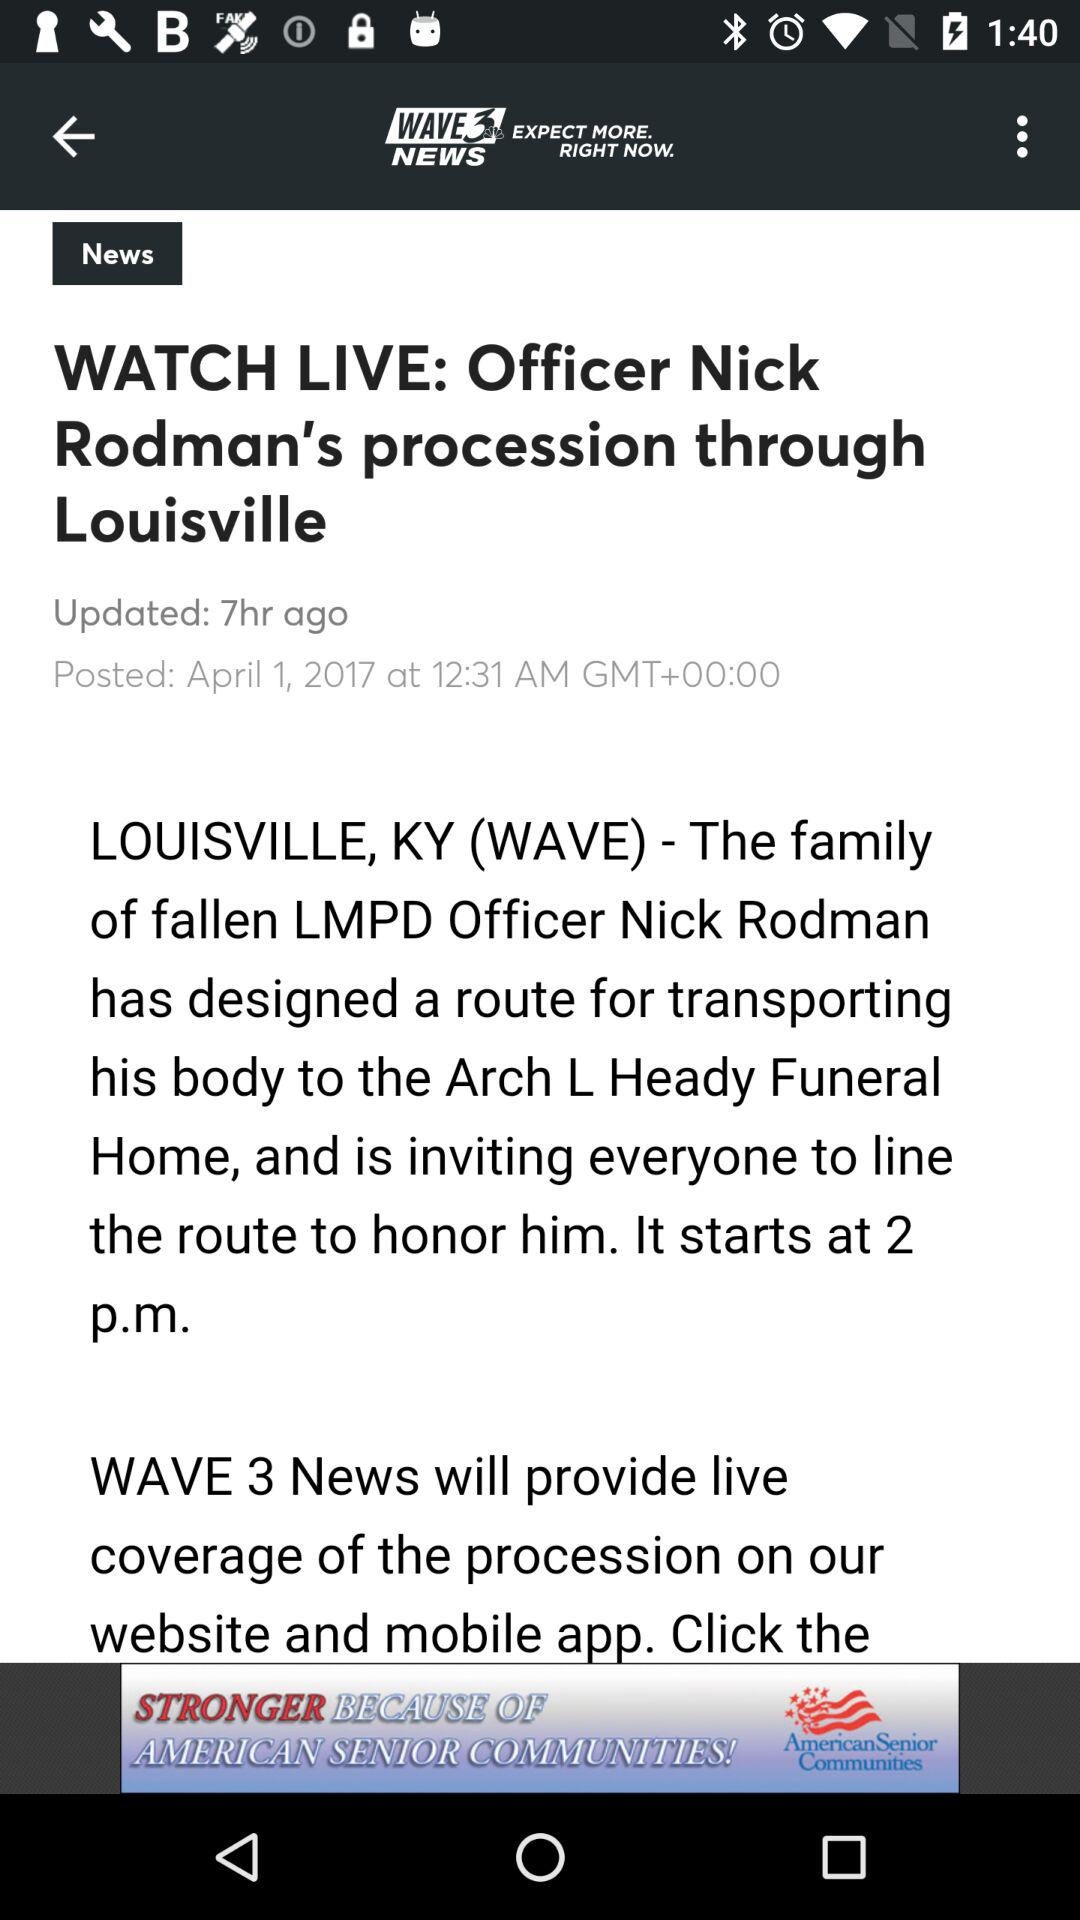When was the article updated? The article was updated 7 hours ago. 